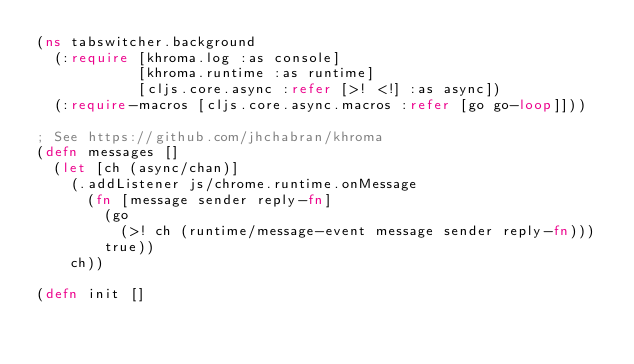<code> <loc_0><loc_0><loc_500><loc_500><_Clojure_>(ns tabswitcher.background
  (:require [khroma.log :as console]
            [khroma.runtime :as runtime]
            [cljs.core.async :refer [>! <!] :as async])
  (:require-macros [cljs.core.async.macros :refer [go go-loop]]))

; See https://github.com/jhchabran/khroma 
(defn messages []
  (let [ch (async/chan)]    
    (.addListener js/chrome.runtime.onMessage 
      (fn [message sender reply-fn]
        (go
          (>! ch (runtime/message-event message sender reply-fn)))
        true))
    ch))

(defn init []</code> 